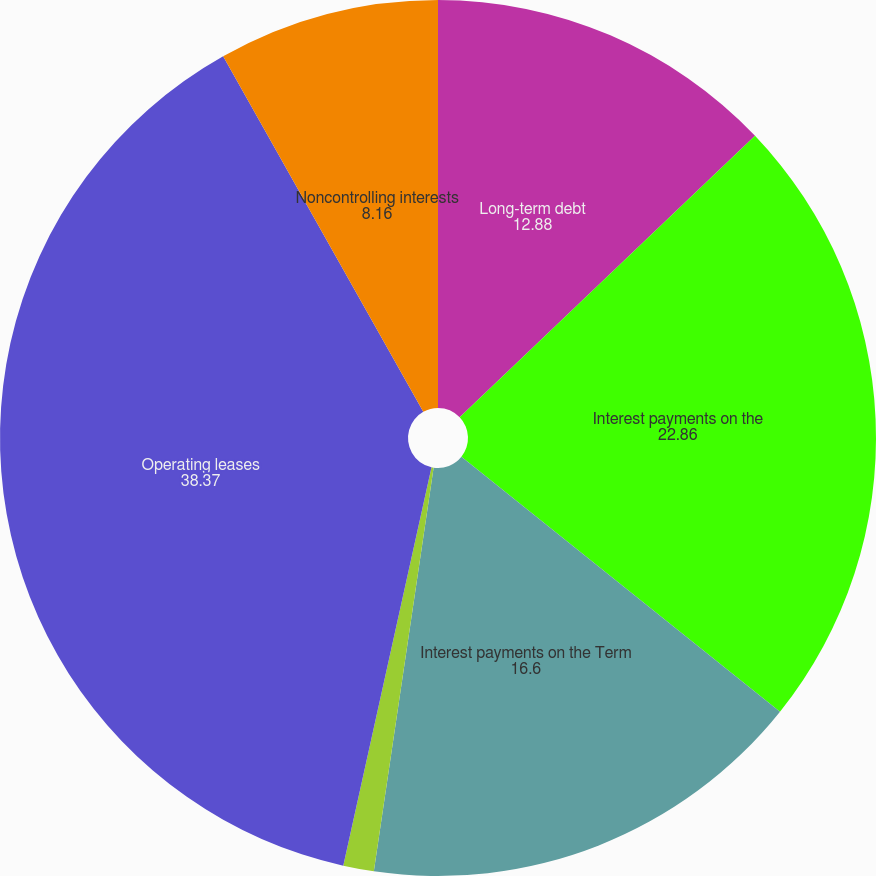<chart> <loc_0><loc_0><loc_500><loc_500><pie_chart><fcel>Long-term debt<fcel>Interest payments on the<fcel>Interest payments on the Term<fcel>Capital lease obligations<fcel>Operating leases<fcel>Noncontrolling interests<nl><fcel>12.88%<fcel>22.86%<fcel>16.6%<fcel>1.13%<fcel>38.37%<fcel>8.16%<nl></chart> 